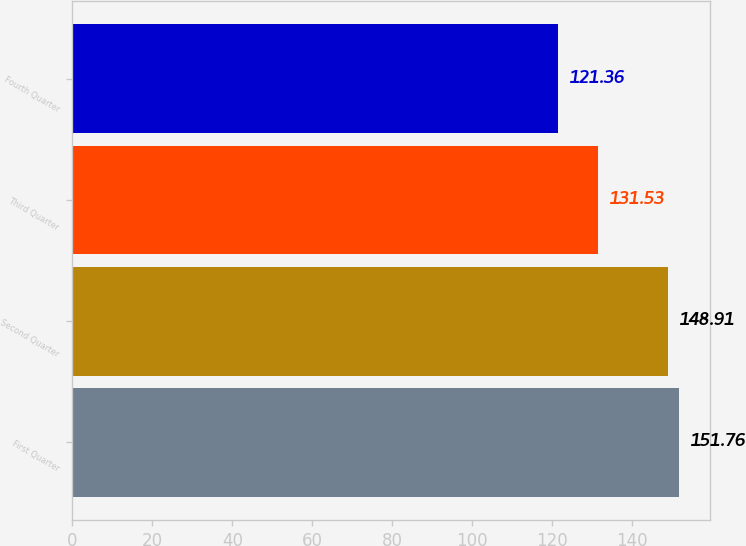Convert chart to OTSL. <chart><loc_0><loc_0><loc_500><loc_500><bar_chart><fcel>First Quarter<fcel>Second Quarter<fcel>Third Quarter<fcel>Fourth Quarter<nl><fcel>151.76<fcel>148.91<fcel>131.53<fcel>121.36<nl></chart> 